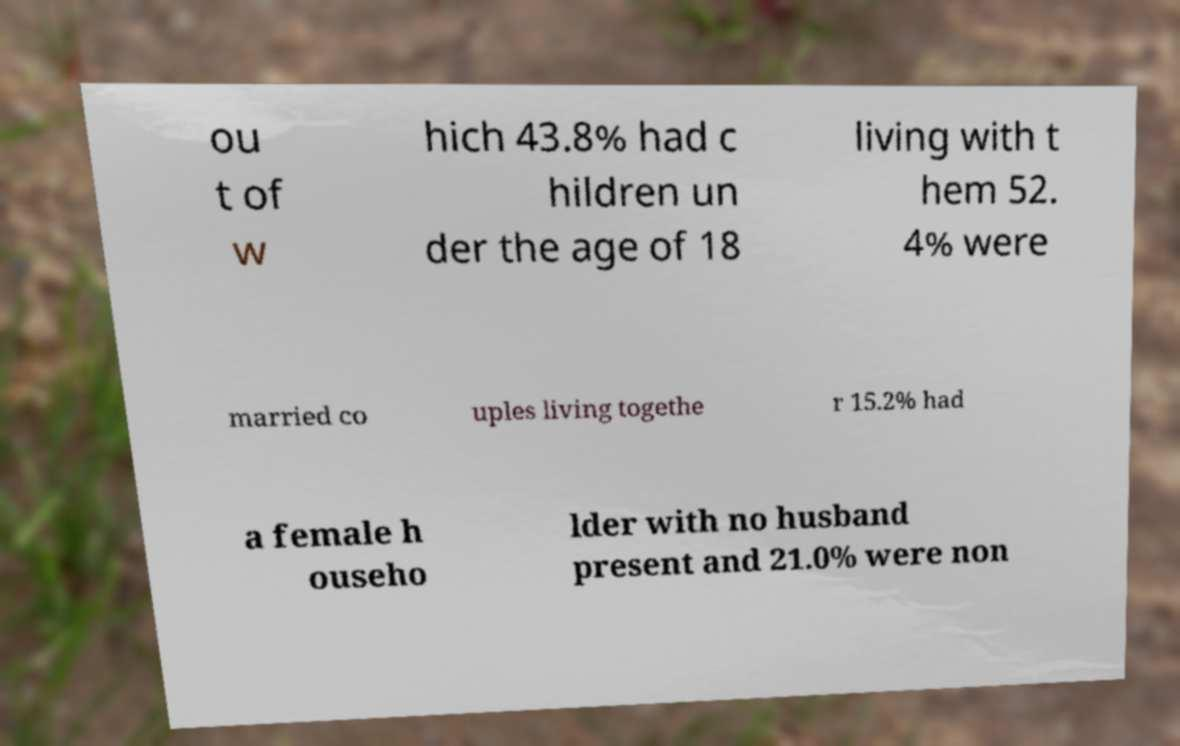What messages or text are displayed in this image? I need them in a readable, typed format. ou t of w hich 43.8% had c hildren un der the age of 18 living with t hem 52. 4% were married co uples living togethe r 15.2% had a female h ouseho lder with no husband present and 21.0% were non 